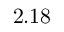<formula> <loc_0><loc_0><loc_500><loc_500>2 . 1 8</formula> 